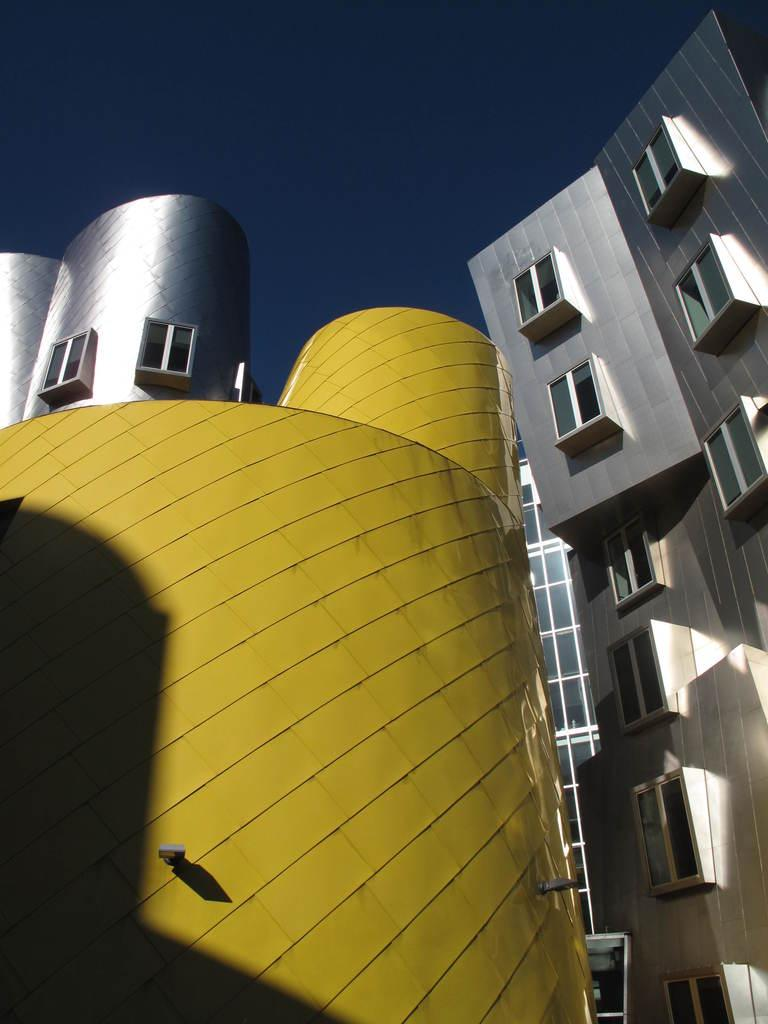What structures are located in the middle of the image? There are buildings in the middle of the image. What is visible at the top of the image? The sky is visible at the top of the image. What type of trick can be seen being performed with a tent in the image? There is no tent or trick present in the image. What is the tin used for in the image? There is no tin present in the image. 